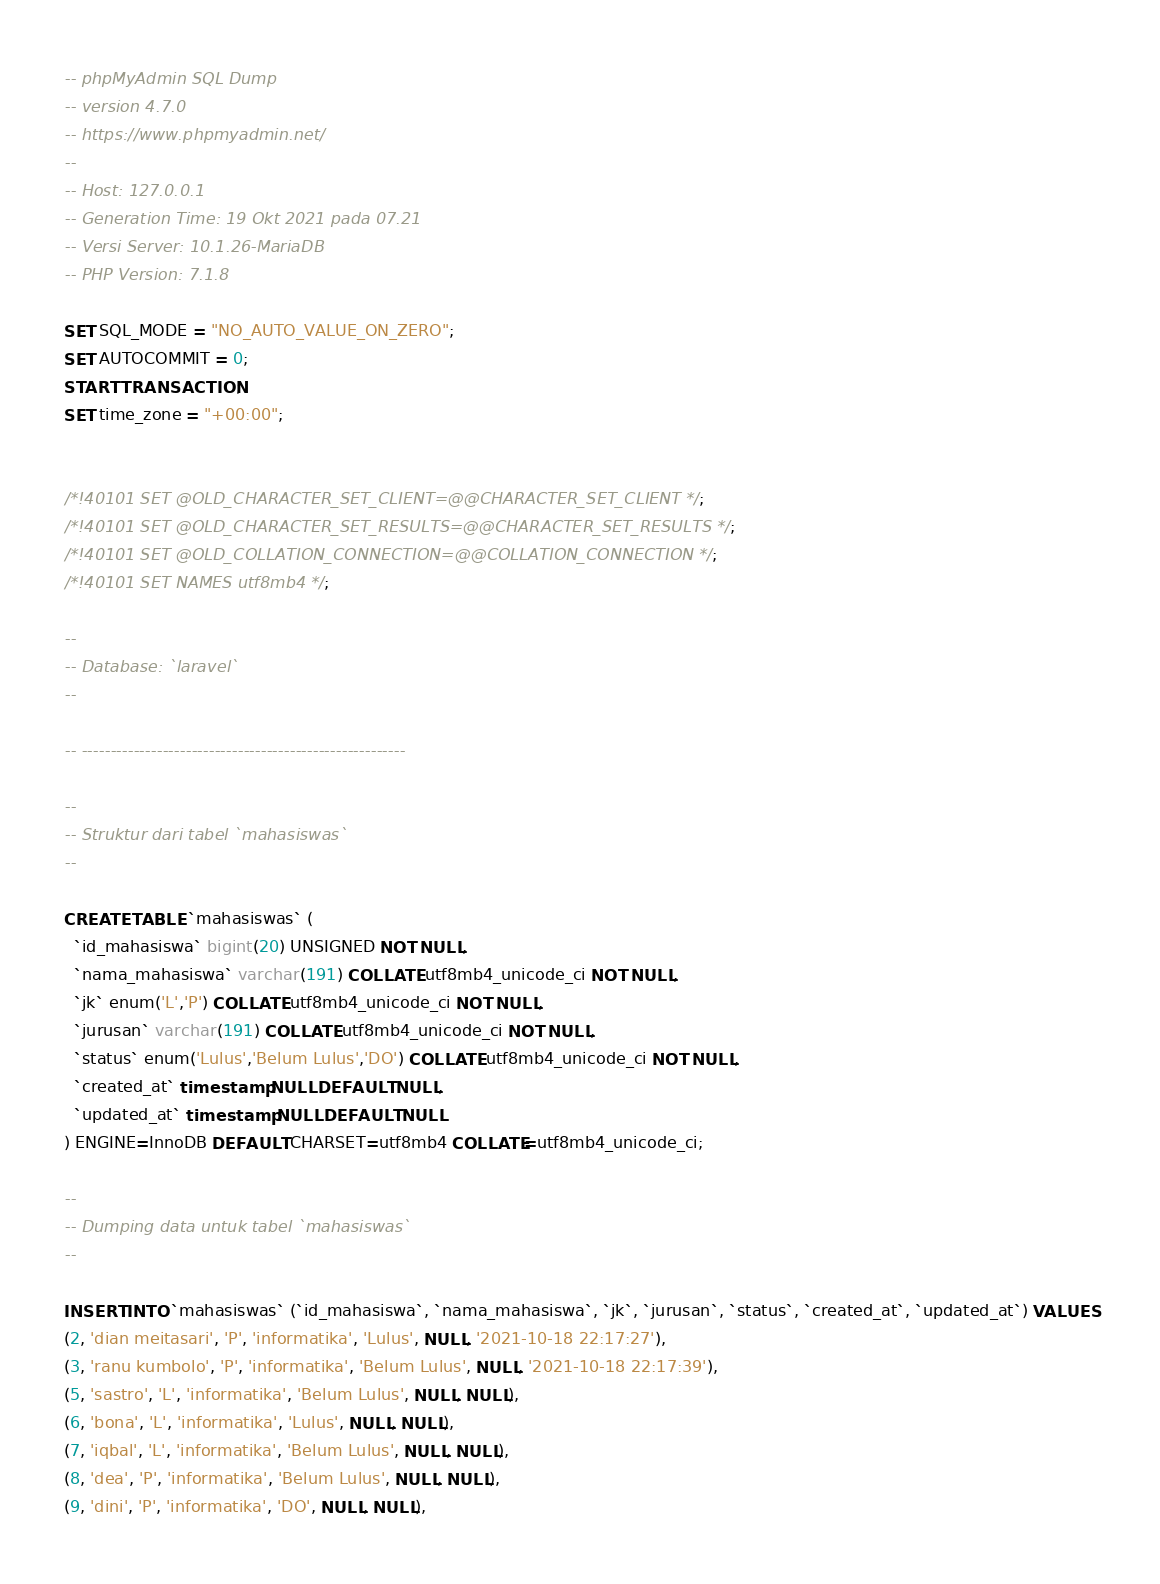Convert code to text. <code><loc_0><loc_0><loc_500><loc_500><_SQL_>-- phpMyAdmin SQL Dump
-- version 4.7.0
-- https://www.phpmyadmin.net/
--
-- Host: 127.0.0.1
-- Generation Time: 19 Okt 2021 pada 07.21
-- Versi Server: 10.1.26-MariaDB
-- PHP Version: 7.1.8

SET SQL_MODE = "NO_AUTO_VALUE_ON_ZERO";
SET AUTOCOMMIT = 0;
START TRANSACTION;
SET time_zone = "+00:00";


/*!40101 SET @OLD_CHARACTER_SET_CLIENT=@@CHARACTER_SET_CLIENT */;
/*!40101 SET @OLD_CHARACTER_SET_RESULTS=@@CHARACTER_SET_RESULTS */;
/*!40101 SET @OLD_COLLATION_CONNECTION=@@COLLATION_CONNECTION */;
/*!40101 SET NAMES utf8mb4 */;

--
-- Database: `laravel`
--

-- --------------------------------------------------------

--
-- Struktur dari tabel `mahasiswas`
--

CREATE TABLE `mahasiswas` (
  `id_mahasiswa` bigint(20) UNSIGNED NOT NULL,
  `nama_mahasiswa` varchar(191) COLLATE utf8mb4_unicode_ci NOT NULL,
  `jk` enum('L','P') COLLATE utf8mb4_unicode_ci NOT NULL,
  `jurusan` varchar(191) COLLATE utf8mb4_unicode_ci NOT NULL,
  `status` enum('Lulus','Belum Lulus','DO') COLLATE utf8mb4_unicode_ci NOT NULL,
  `created_at` timestamp NULL DEFAULT NULL,
  `updated_at` timestamp NULL DEFAULT NULL
) ENGINE=InnoDB DEFAULT CHARSET=utf8mb4 COLLATE=utf8mb4_unicode_ci;

--
-- Dumping data untuk tabel `mahasiswas`
--

INSERT INTO `mahasiswas` (`id_mahasiswa`, `nama_mahasiswa`, `jk`, `jurusan`, `status`, `created_at`, `updated_at`) VALUES
(2, 'dian meitasari', 'P', 'informatika', 'Lulus', NULL, '2021-10-18 22:17:27'),
(3, 'ranu kumbolo', 'P', 'informatika', 'Belum Lulus', NULL, '2021-10-18 22:17:39'),
(5, 'sastro', 'L', 'informatika', 'Belum Lulus', NULL, NULL),
(6, 'bona', 'L', 'informatika', 'Lulus', NULL, NULL),
(7, 'iqbal', 'L', 'informatika', 'Belum Lulus', NULL, NULL),
(8, 'dea', 'P', 'informatika', 'Belum Lulus', NULL, NULL),
(9, 'dini', 'P', 'informatika', 'DO', NULL, NULL),</code> 